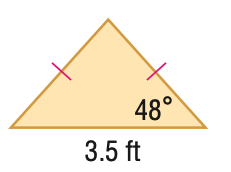Answer the mathemtical geometry problem and directly provide the correct option letter.
Question: Find the area of the triangle. Round to the nearest hundredth.
Choices: A: 1.70 B: 2.76 C: 3.40 D: 6.80 C 